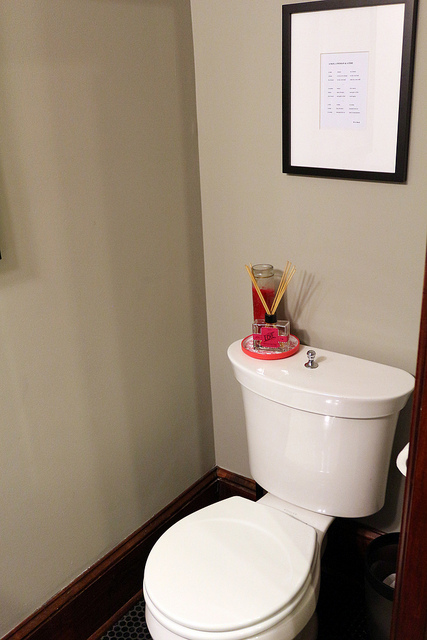Can you tell me what items are on top of the toilet tank? On top of the toilet tank, there appears to be a decorative item, possibly a reed diffuser, along with a couple of tall sticks or reeds sticking out of it, which are often used to diffuse scent into the room. 